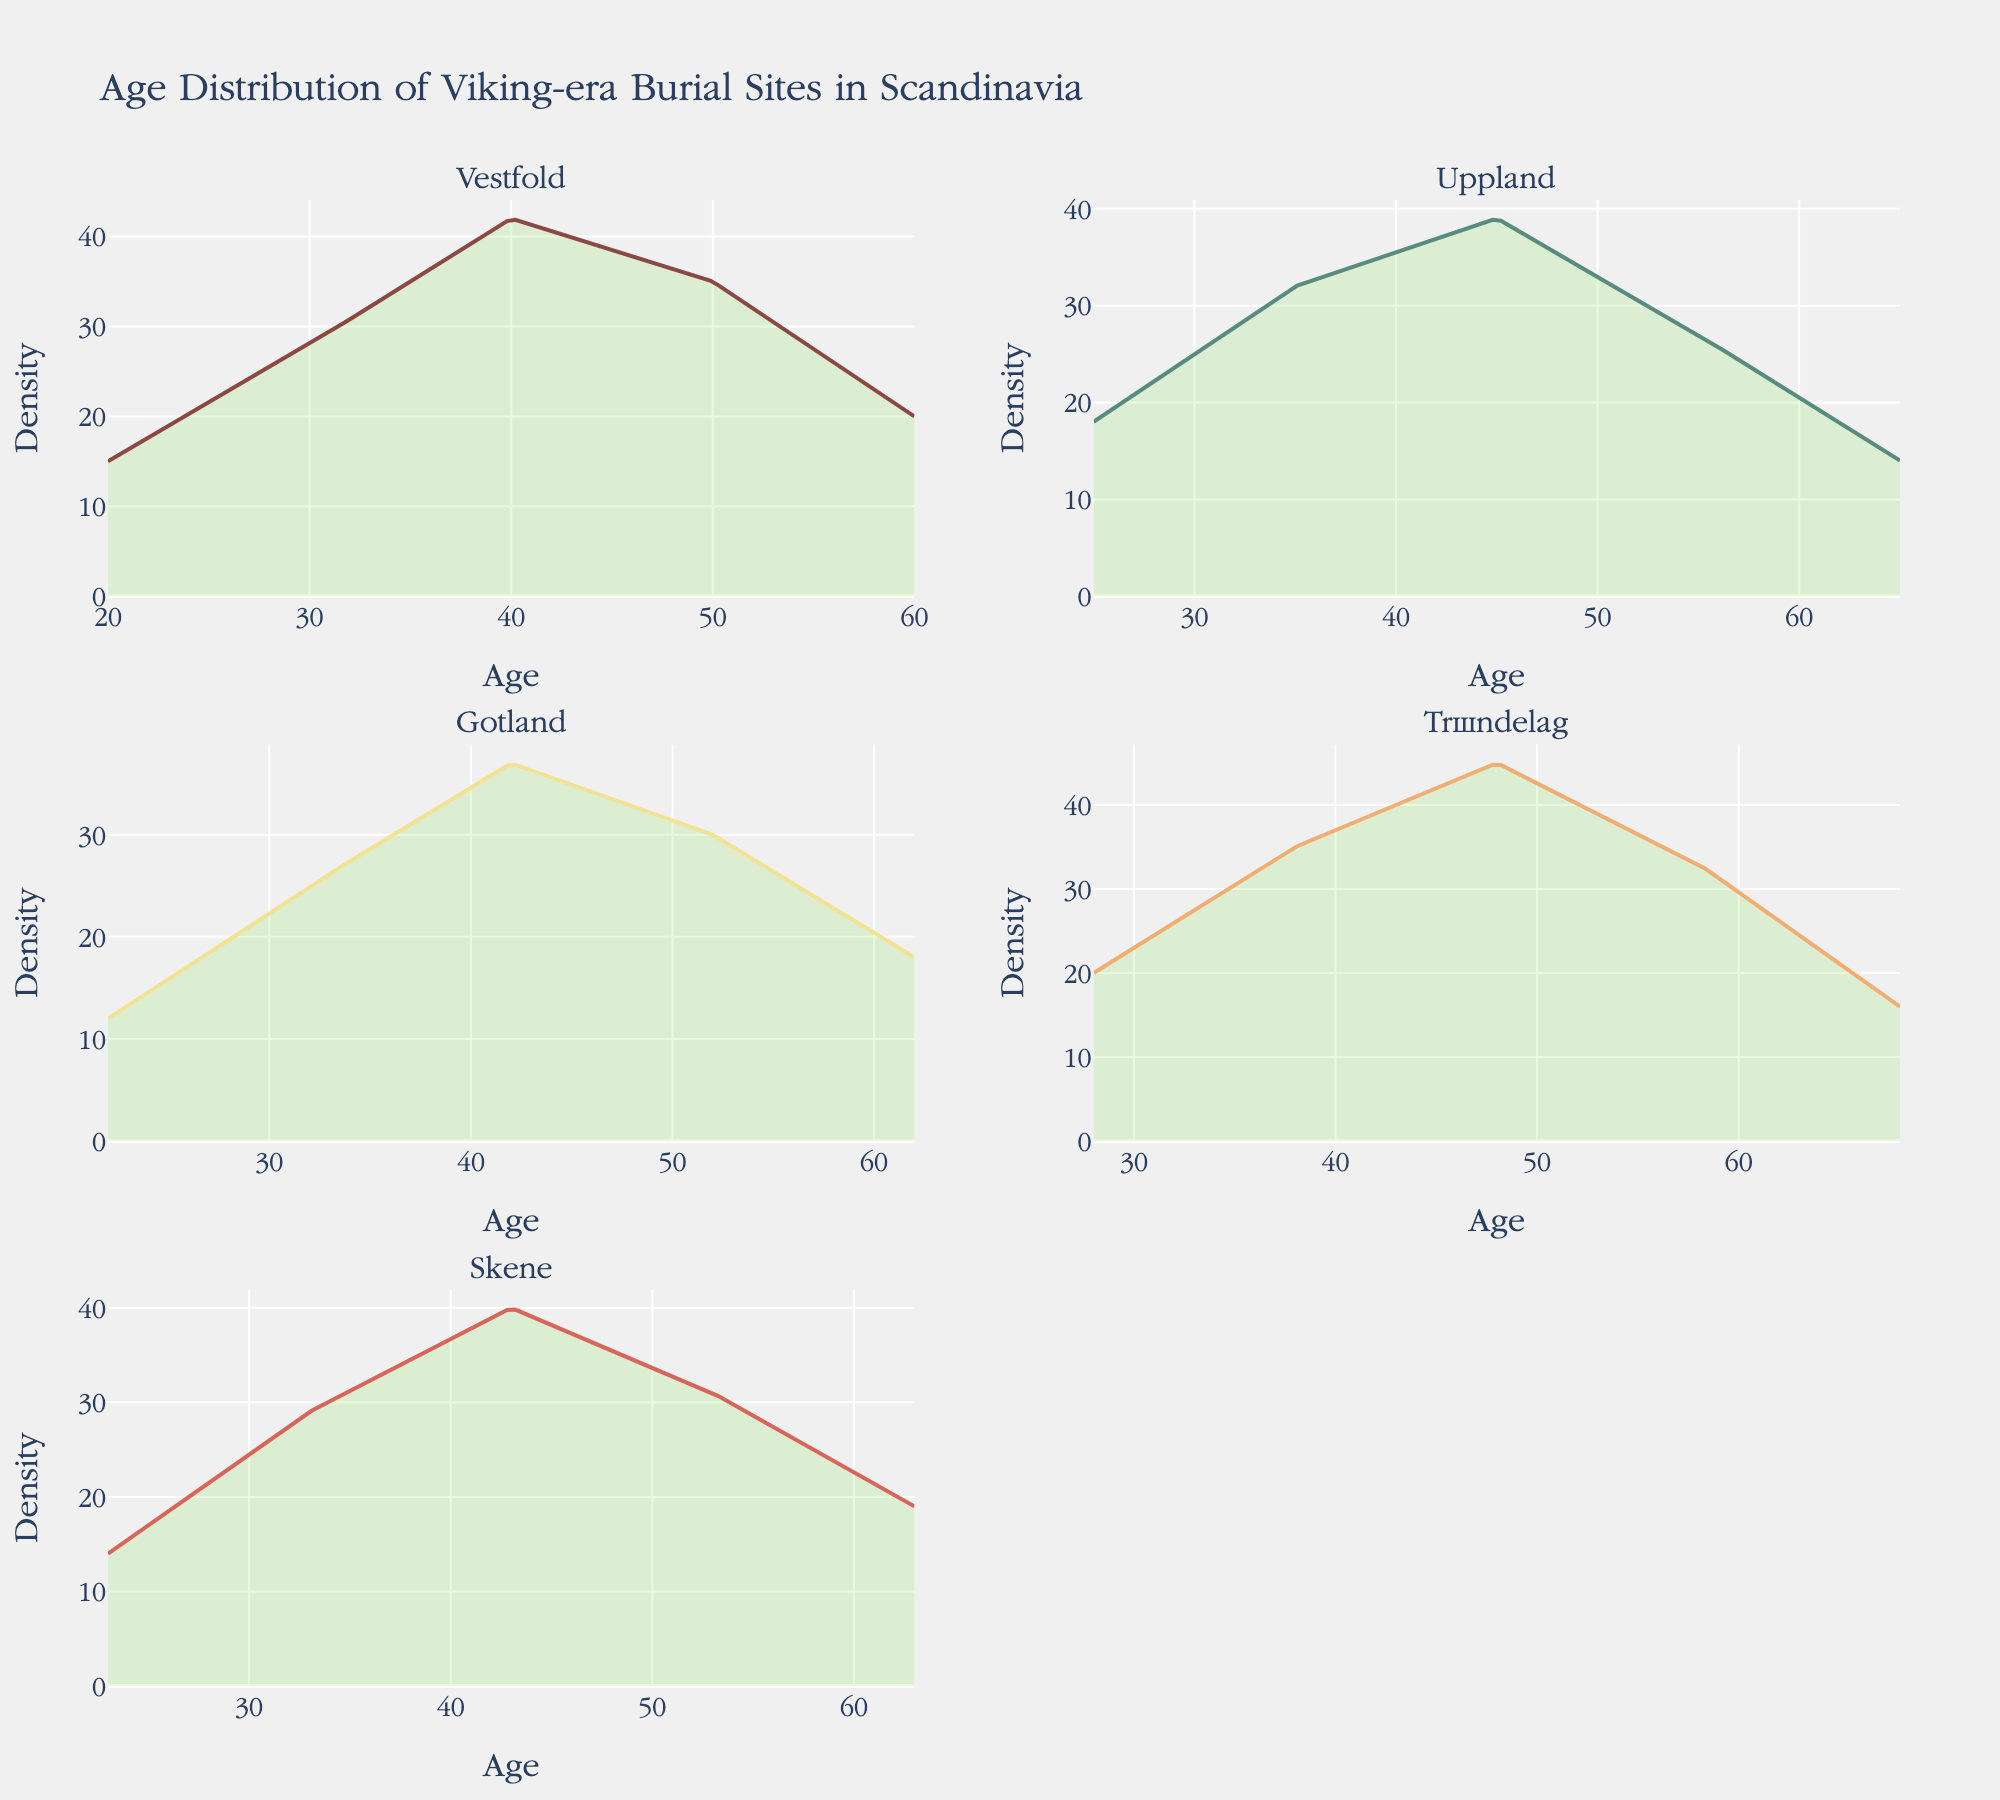What is the title of the plot? The title is usually placed at the top of the plot and it provides a summary of what the plot represents.
Answer: "Age Distribution of Viking-era Burial Sites in Scandinavia" Which region has the highest density peak? The highest density peak can be identified by looking at the subplot with the highest peak value on the y-axis. Each region is represented by its own subplot.
Answer: Trøndelag At what age does Vestfold reach its highest density? By examining the Vestfold subplot, you can see the age value on the x-axis where the density curve reaches its maximum value on the y-axis.
Answer: 40 Which regions have their density peaks occur at age 45? Compare the subplots to see which density curves peak at the age of 45 on the x-axis.
Answer: Uppland, Trøndelag How much higher is the peak density of Trøndelag than Gotland? First, identify the peak density values of Trøndelag and Gotland by looking at their subplots. Then, subtract the value for Gotland from the value for Trøndelag.
Answer: 8 Which region has the widest age range with significant densities? Look at the range of ages with non-zero density values in each subplot. The region with the most extensive range is the one with the widest age range for significant densities.
Answer: Trøndelag Do any regions show a marked decrease in density after age 50? Examine the density curves after age 50 for each region. Identify which regions have noticeable declines in density after this age.
Answer: Vestfold, Skåne, Uppland, Gotland, Trøndelag At what age does Gotland reach its second-highest density peak? Inspect Gotland's subplot to find the second-highest peak. Note where this peak occurs on the age axis.
Answer: 52 Is there a region where the density consistently increases until a peak and then steadily decreases? Look for a subplot where the density values rise without fluctuation until reaching a peak and then decline without increasing again.
Answer: Yes, Skåne What is the difference in peak densities between Vestfold and Uppland? Identify the maximum density values in the Vestfold and Uppland subplots. Subtract the lower peak value from the higher one to find the difference.
Answer: 3 